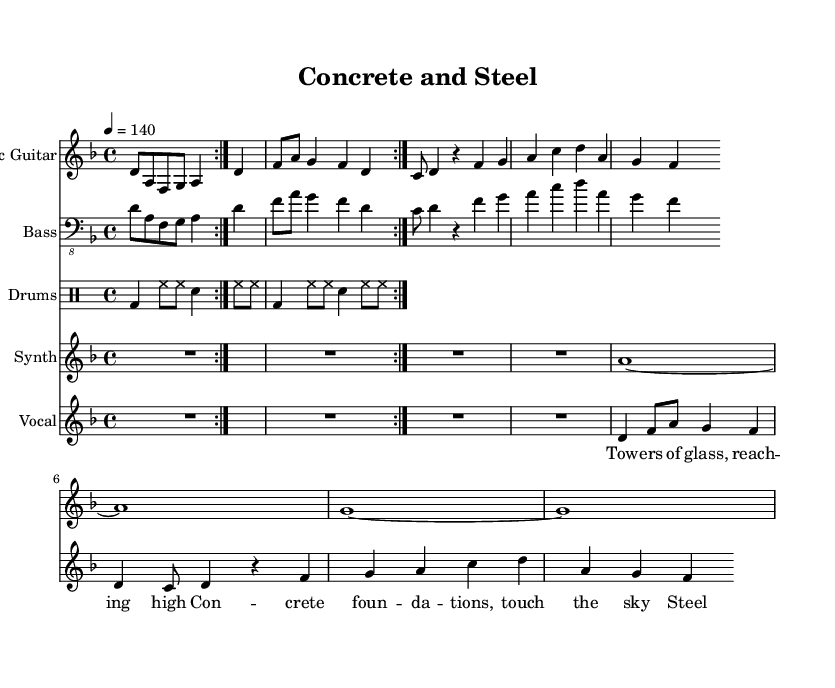What is the key signature of this music? The key signature is D minor, which contains one flat (B flat). This is determined by looking at the key signature indicated at the beginning of the score.
Answer: D minor What is the time signature of this music? The time signature is 4/4, which means there are four beats in each measure and a quarter note gets one beat. This is evident from the time signature displayed at the beginning of the score.
Answer: 4/4 What is the tempo marking for this piece? The tempo marking indicates that the piece should be played at a speed of 140 beats per minute, which is indicated by the tempo notation in the score.
Answer: 140 How many measures are in the guitar part before the first repeat? There are 4 measures in the guitar part before the repeating section starts. This can be counted directly from the guitar staff, where measures are segmented by vertical lines.
Answer: 4 What type of vocal technique is employed in the lyrics? The lyrics are structured in a rhythmic and lyrical pattern typical of metal music, often addressing themes of urban architecture and modernity, which can indicate a combination of spoken and sung techniques.
Answer: Spoken and sung What do the lyrics "Steel and stone, our urban home" suggest about the theme of the music? The lyrics imply a connection between the industrial materials commonly used in architecture (steel and stone) and the concept of urban living, reflecting themes relevant to industrial metal. This suggests a focus on modern life in an urban landscape.
Answer: Urban life How is the drumming pattern structured in relation to the guitar part? The drumming pattern complements the guitar part by maintaining a steady beat, often with bass drum hits aligning with the strong beats of the guitar, establishing a cohesive rhythmic foundation typical in metal music.
Answer: Cohesive rhythmic foundation 